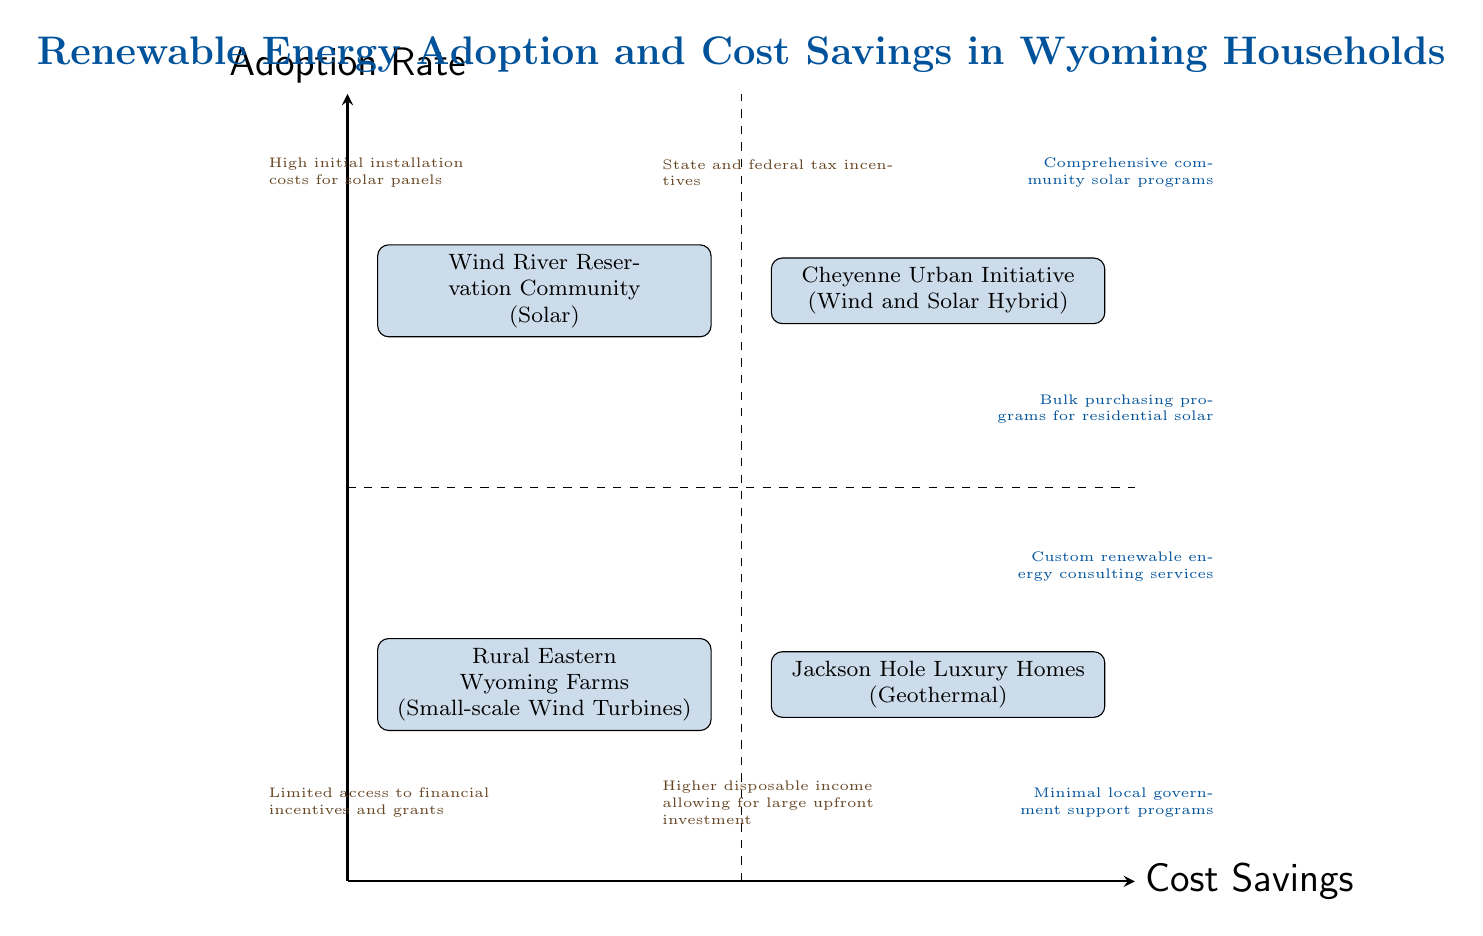What households are in the High Adoption Low Savings quadrant? In the High Adoption Low Savings quadrant, the households listed are "Wind River Reservation Community". This is determined by locating the specific quadrant on the diagram that corresponds to high adoption rates and low cost savings.
Answer: Wind River Reservation Community What energy source is used in the Low Adoption High Savings quadrant? The energy source used in the Low Adoption High Savings quadrant is "Geothermal". This is identified by checking which household is in that quadrant and noting the specified energy source.
Answer: Geothermal How many quadrants are displayed in this diagram? The diagram displays a total of four quadrants: High Adoption Low Savings, High Adoption High Savings, Low Adoption Low Savings, and Low Adoption High Savings. This is counted by identifying each labeled area in the chart.
Answer: 4 Which household benefits from comprehensive community solar programs? The household that benefits from comprehensive community solar programs is the "Wind River Reservation Community". This information is provided alongside the quadrant it occupies.
Answer: Wind River Reservation Community What are the economic factors affecting the Cheyenne Urban Initiative? The economic factors affecting the Cheyenne Urban Initiative include "State and federal tax incentives". This factor is noted in the quadrant associated with this household.
Answer: State and federal tax incentives What is the support system mentioned for Jackson Hole Luxury Homes? The support system mentioned for Jackson Hole Luxury Homes is "Custom renewable energy consulting services". This detail can be found listed within the appropriate quadrant for that household.
Answer: Custom renewable energy consulting services Which quadrant has minimal local government support programs? The quadrant with minimal local government support programs is the "Low Adoption Low Savings" quadrant, which corresponds to the Rural Eastern Wyoming Farms. This is concluded by identifying the specific quadrant and its contents.
Answer: Low Adoption Low Savings What economic factors are listed for Rural Eastern Wyoming Farms? The economic factors listed for Rural Eastern Wyoming Farms are "Limited access to financial incentives and grants". This is determined by referencing the relevant quadrant where this household is located.
Answer: Limited access to financial incentives and grants What is the relationship between adoption rate and cost savings in the High Adoption High Savings quadrant? The relationship in the High Adoption High Savings quadrant indicates that there is a high adoption rate coinciding with high cost savings. This is inferred from the placement of the households in that specific quadrant of the diagram.
Answer: High adoption and high savings 